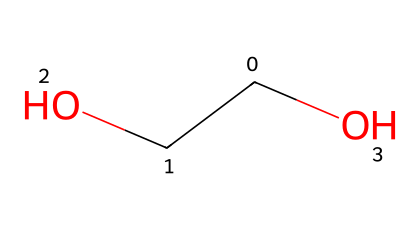What is the molecular formula of the compound represented by the SMILES? The SMILES representation corresponds to the chemical C(CO)O, which indicates the arrangement of carbon (C), hydrogen (H), and oxygen (O) atoms. The molecular formula can be derived from the counts of these atoms, leading to C2H6O.
Answer: C2H6O How many carbon atoms are present in this chemical? By analyzing the SMILES, the first character 'C' indicates one carbon atom, and the second 'C' before '(CO)' indicates another carbon atom. Therefore, there are two carbon atoms in total.
Answer: 2 What type of functional group does this SMILES contain? The SMILES includes the 'O' directly connected to 'C' with another 'C' and 'OH' indicating the presence of a hydroxyl group (-OH). This indicates it's an alcohol, as it has the -OH functional group.
Answer: alcohol Does this compound exhibit non-Newtonian fluid behaviors? Polyethylene oxide (PEO) is known to share non-Newtonian properties, especially at higher molecular weights. The structure indicates it could form such fluids, as is common with polymers like PEO when dissolved in water.
Answer: yes What role does the hydroxyl group play in the properties of slime? The hydroxyl group in the structure increases the solubility of the polymer in water, allowing for better interactions with the water molecules, which contributes to the slime's viscosity and elasticity.
Answer: increases viscosity How does the molecular weight of polyethylene oxide affect its non-Newtonian behavior? Higher molecular weight indicates longer chains, which enhance entanglement and interaction between polymer chains, leading to a more pronounced non-Newtonian behavior such as shear-thinning or thickening in different conditions.
Answer: increases complexity 